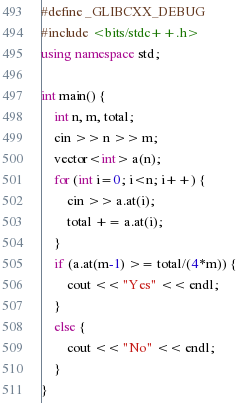<code> <loc_0><loc_0><loc_500><loc_500><_C++_>#define _GLIBCXX_DEBUG
#include <bits/stdc++.h>
using namespace std;

int main() {
    int n, m, total;
    cin >> n >> m;
    vector<int> a(n);
    for (int i=0; i<n; i++) {
        cin >> a.at(i);
        total += a.at(i);
    }
    if (a.at(m-1) >= total/(4*m)) {
        cout << "Yes" << endl;
    }
    else {
        cout << "No" << endl;
    }
}</code> 